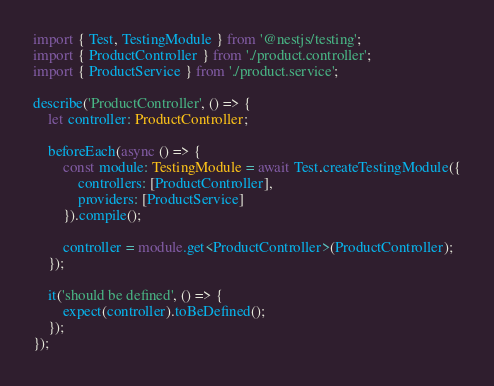Convert code to text. <code><loc_0><loc_0><loc_500><loc_500><_TypeScript_>import { Test, TestingModule } from '@nestjs/testing';
import { ProductController } from './product.controller';
import { ProductService } from './product.service';

describe('ProductController', () => {
	let controller: ProductController;

	beforeEach(async () => {
		const module: TestingModule = await Test.createTestingModule({
			controllers: [ProductController],
			providers: [ProductService]
		}).compile();

		controller = module.get<ProductController>(ProductController);
	});

	it('should be defined', () => {
		expect(controller).toBeDefined();
	});
});
</code> 